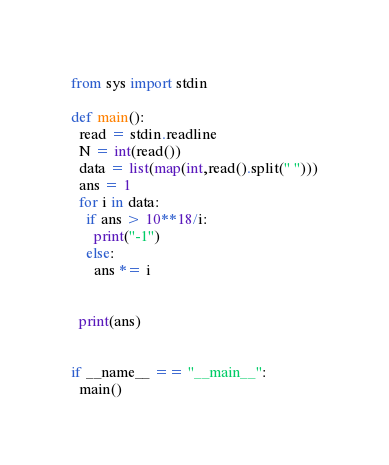<code> <loc_0><loc_0><loc_500><loc_500><_Python_>from sys import stdin

def main():
  read = stdin.readline
  N = int(read())
  data = list(map(int,read().split(" ")))
  ans = 1
  for i in data:
    if ans > 10**18/i:
      print("-1")
    else:
      ans *= i
      
    
  print(ans)
  
  
if __name__ == "__main__":
  main()</code> 